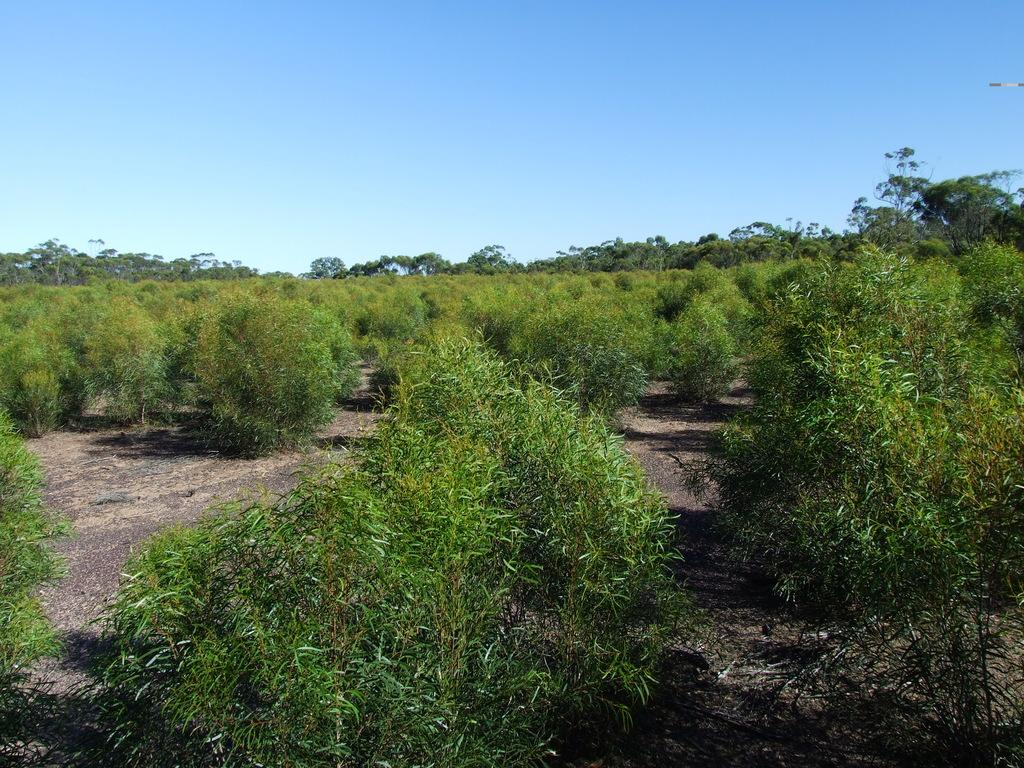What type of vegetation is present on the ground in the image? There are plants with green leaves on the ground. What can be seen in the background of the image? There are trees and the sky visible in the background of the image. What type of cable can be seen hanging from the trees in the image? There is no cable present in the image; it only features plants, trees, and the sky. 